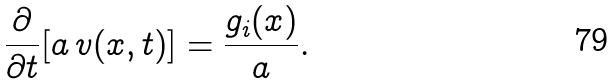<formula> <loc_0><loc_0><loc_500><loc_500>\frac { \partial } { \partial t } [ a \, v ( x , t ) ] = \frac { g _ { i } ( x ) } { a } .</formula> 